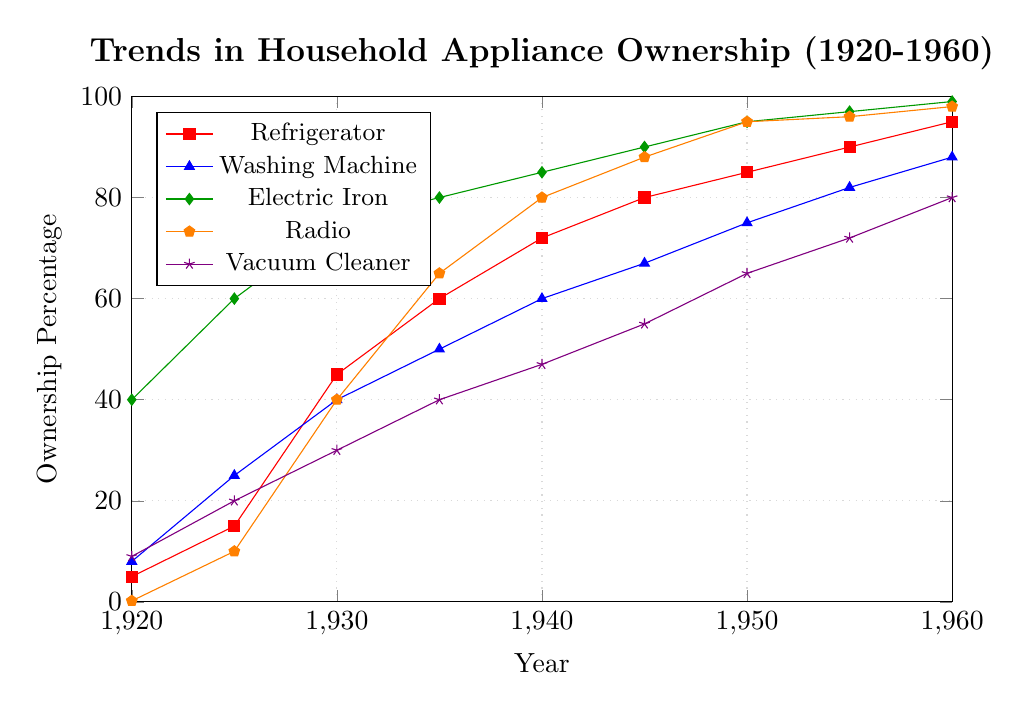What appliance showed the most significant increase in ownership from 1920 to 1960? By observing the lines, the increase is calculated as the difference in ownership percentage from 1920 to 1960. The appliance with the steepest increase is the Electric Iron (99% - 40% = 59%).
Answer: Electric Iron Which appliance had the lowest ownership percentage in 1920, and what was it? By visually inspecting the starting points of each line at the year 1920, the Radio had the lowest ownership percentage at 0.2%.
Answer: Radio, 0.2% Which year did Radios reach 50% ownership? By tracking the orange line, we see that Radio ownership reaches around 50% between 1935 and 1940. More precisely, it hits 65% in 1935.
Answer: 1935 Compare the ownership of Washing Machines and Vacuum Cleaners in 1950. Which had higher ownership and by how much? By comparing the values for 1950 on the lines for Washing Machines and Vacuum Cleaners: 75% (Washing Machine) and 65% (Vacuum Cleaner). The Washing Machine had a higher ownership by 75% - 65% = 10%.
Answer: Washing Machine by 10% Calculate the average ownership level of Refrigerators from 1920 to 1960. The values are 5, 15, 45, 60, 72, 80, 85, 90, 95. Sum these values to get 547, then divide by 9 (number of data points) to get an average. 547/9 ≈ 60.78
Answer: 60.78% Identify the decade (1930s, 1940s, 1950s) in which electric irons saw the smallest growth. Comparing the differences in ownership in each decade: 1930s (75% - 60% = 15%), 1940s (95% - 85% = 10%), 1950s (99% - 95% = 4%), the 1950s had the smallest growth (4%).
Answer: 1950s What's the difference in ownership percentage between Vacuum Cleaners and Washing Machines in 1930? By looking at the values in 1930: Vacuum Cleaners (30%) and Washing Machines (40%). The difference is 40% - 30% = 10%.
Answer: 10% Which appliance reached near-complete saturation (almost 100% ownership) first, and in which year? The Electric Iron reached 99% in 1960 and thus reached near-complete saturation first.
Answer: Electric Iron, 1960 